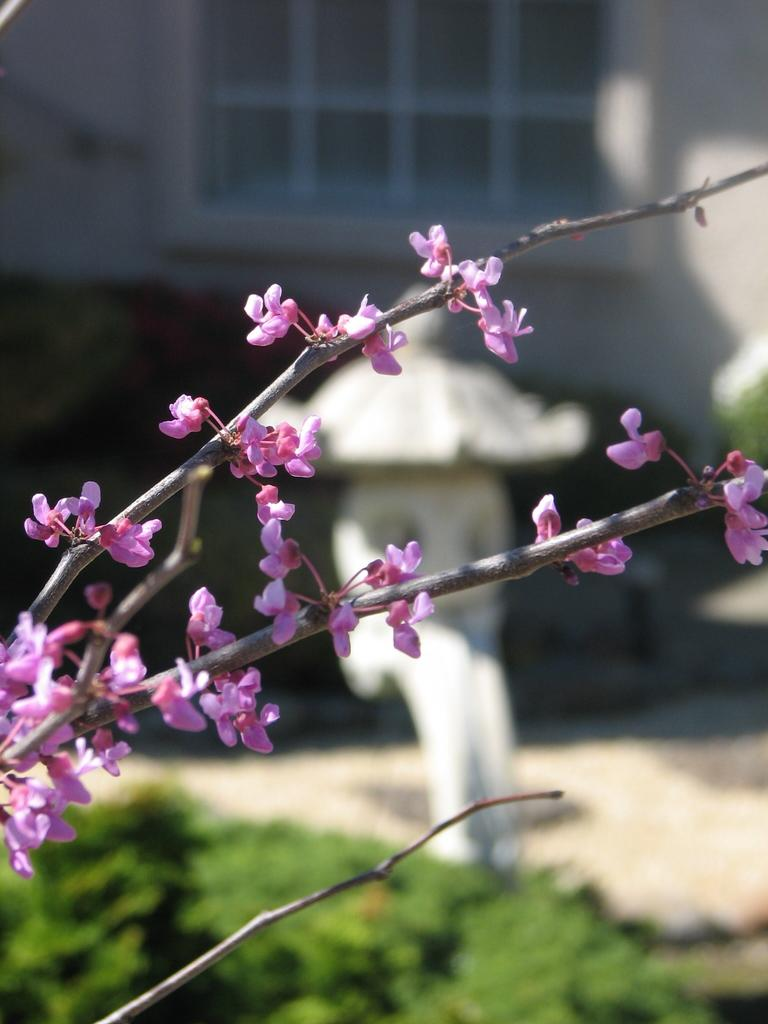What type of flora can be seen in the image? There are flowers and plants in the image. How is the background of the image depicted? The background of the image is blurred. What architectural feature is present in the image? There is a window and a wall in the image. What type of baseball effect can be seen in the image? There is no baseball or any related effect present in the image. Can you describe the ocean in the image? There is no ocean present in the image. 